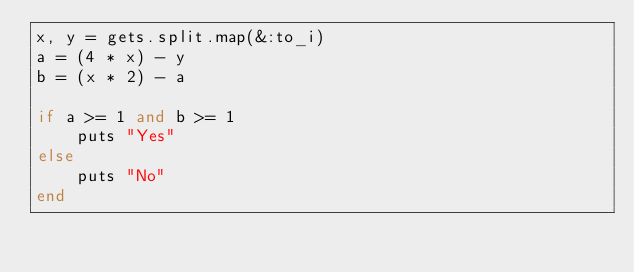<code> <loc_0><loc_0><loc_500><loc_500><_Ruby_>x, y = gets.split.map(&:to_i)
a = (4 * x) - y
b = (x * 2) - a

if a >= 1 and b >= 1
    puts "Yes"
else
    puts "No"
end
</code> 